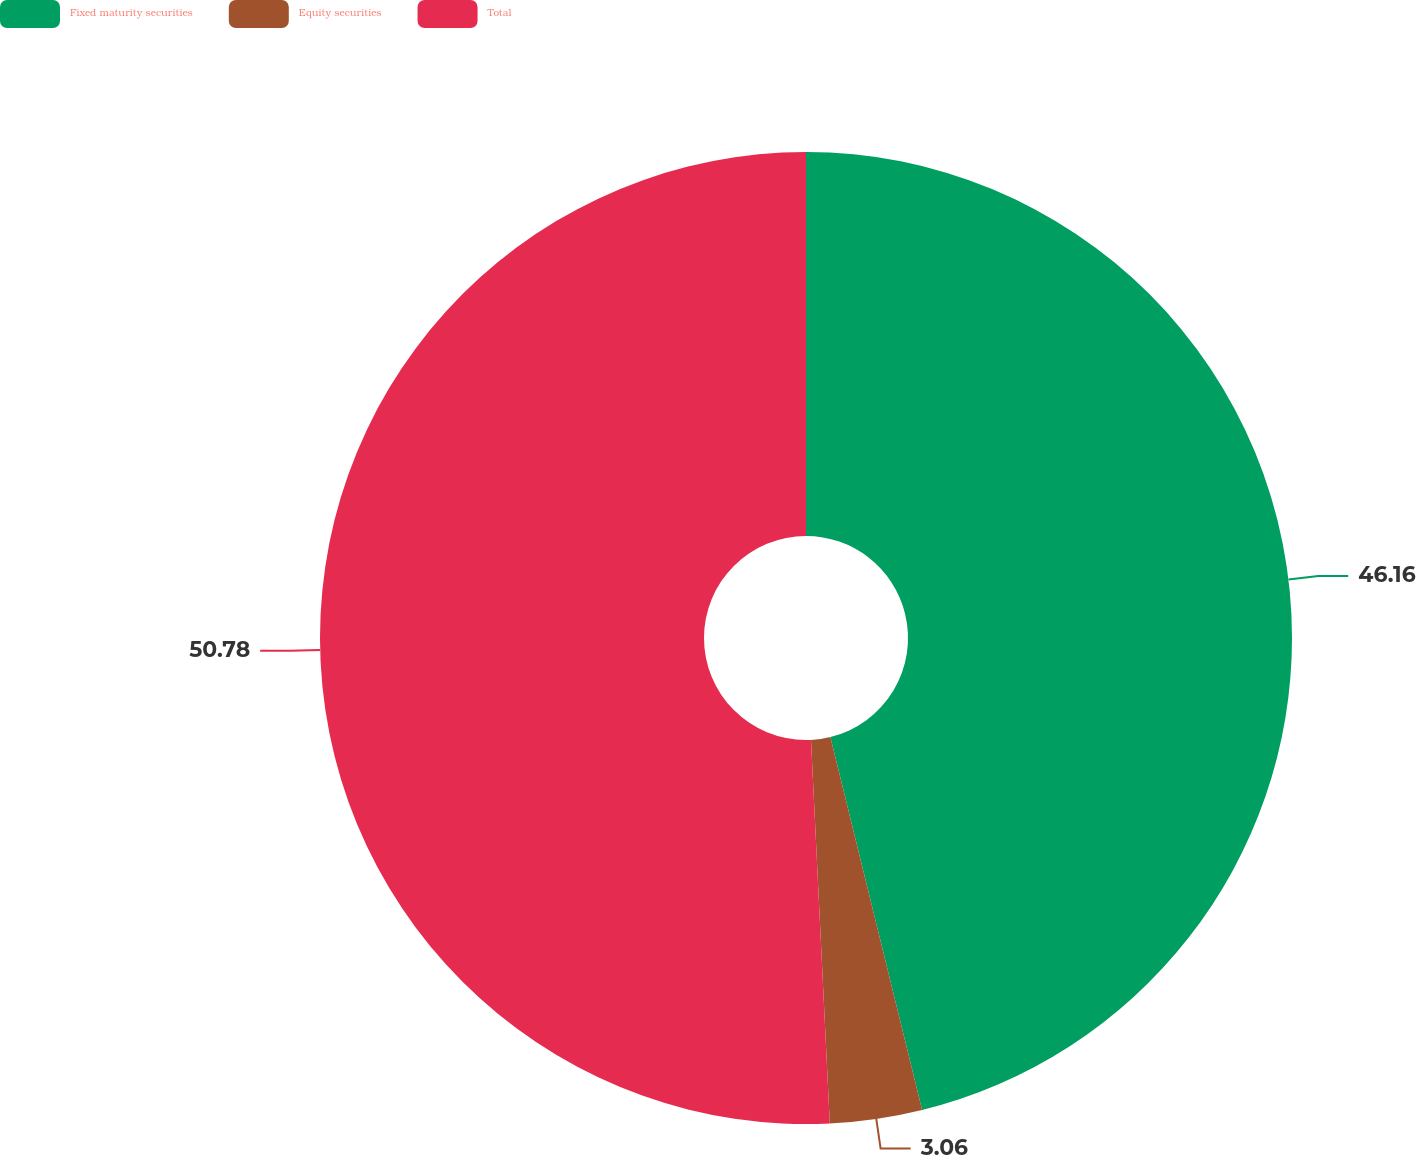Convert chart to OTSL. <chart><loc_0><loc_0><loc_500><loc_500><pie_chart><fcel>Fixed maturity securities<fcel>Equity securities<fcel>Total<nl><fcel>46.16%<fcel>3.06%<fcel>50.78%<nl></chart> 